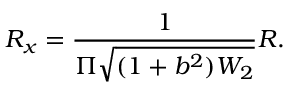Convert formula to latex. <formula><loc_0><loc_0><loc_500><loc_500>R _ { x } = \frac { 1 } { \Pi \sqrt { ( 1 + b ^ { 2 } ) W _ { 2 } } } R .</formula> 